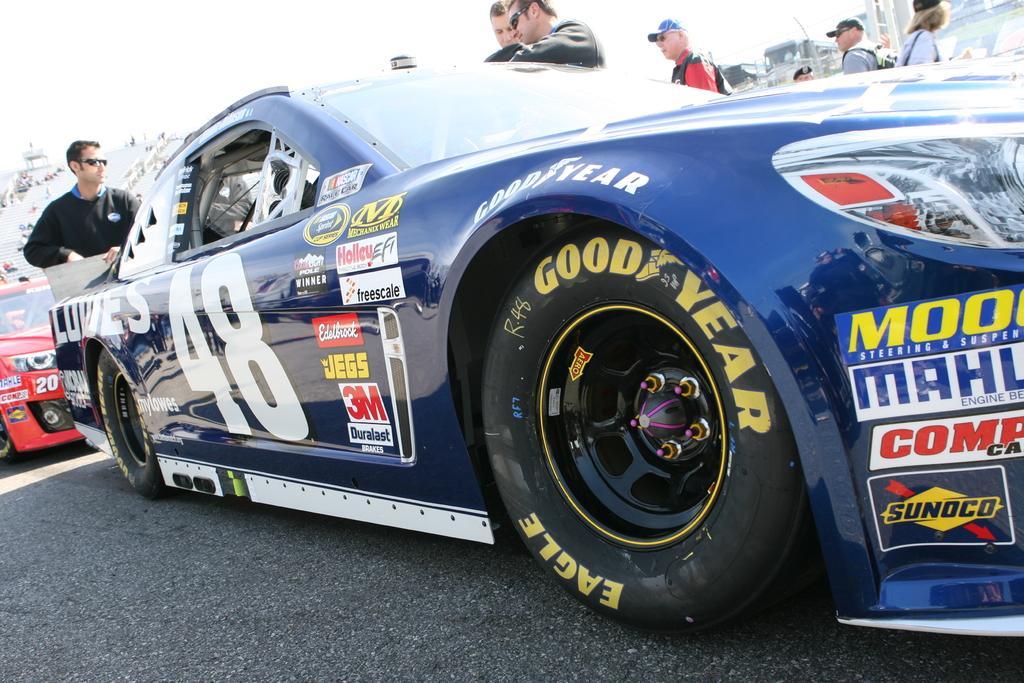Can you describe this image briefly? In this image in front there are cars on the road. Beside the cars there are few people standing on the road. Behind them there are two buses. On the left side of the image people are sitting on the stairs. 